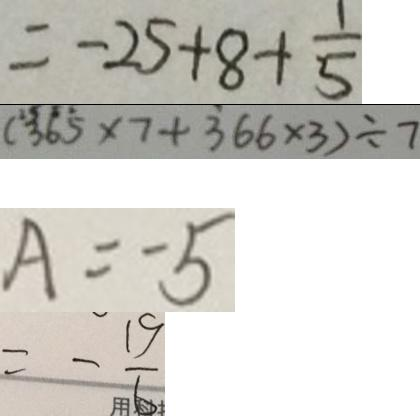Convert formula to latex. <formula><loc_0><loc_0><loc_500><loc_500>= - 2 5 + 8 + \frac { 1 } { 5 } 
 ( 3 6 5 \times 7 + 3 6 6 \times 3 ) \div 7 
 A = 5 
 = - \frac { 1 9 } { 6 }</formula> 